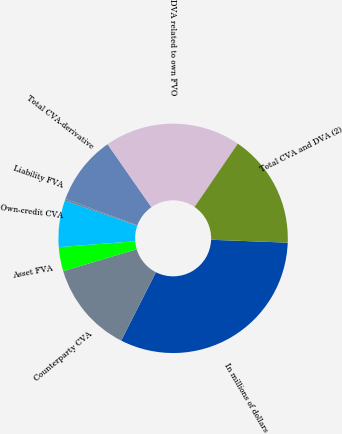Convert chart. <chart><loc_0><loc_0><loc_500><loc_500><pie_chart><fcel>In millions of dollars<fcel>Counterparty CVA<fcel>Asset FVA<fcel>Own-credit CVA<fcel>Liability FVA<fcel>Total CVA-derivative<fcel>DVA related to own FVO<fcel>Total CVA and DVA (2)<nl><fcel>31.88%<fcel>12.9%<fcel>3.4%<fcel>6.57%<fcel>0.24%<fcel>9.73%<fcel>19.22%<fcel>16.06%<nl></chart> 